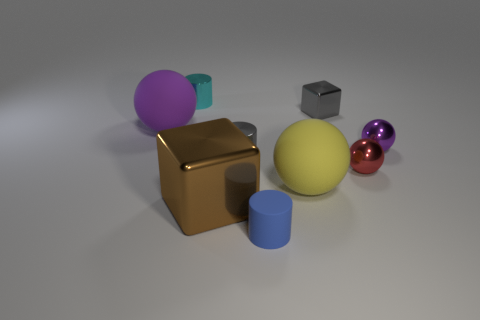Subtract all blue cubes. How many purple spheres are left? 2 Subtract all tiny rubber cylinders. How many cylinders are left? 2 Subtract 1 cylinders. How many cylinders are left? 2 Subtract all yellow spheres. How many spheres are left? 3 Add 1 large purple metallic things. How many objects exist? 10 Subtract all blocks. How many objects are left? 7 Subtract 1 gray cylinders. How many objects are left? 8 Subtract all red spheres. Subtract all green cylinders. How many spheres are left? 3 Subtract all cyan objects. Subtract all small purple balls. How many objects are left? 7 Add 9 cyan metal things. How many cyan metal things are left? 10 